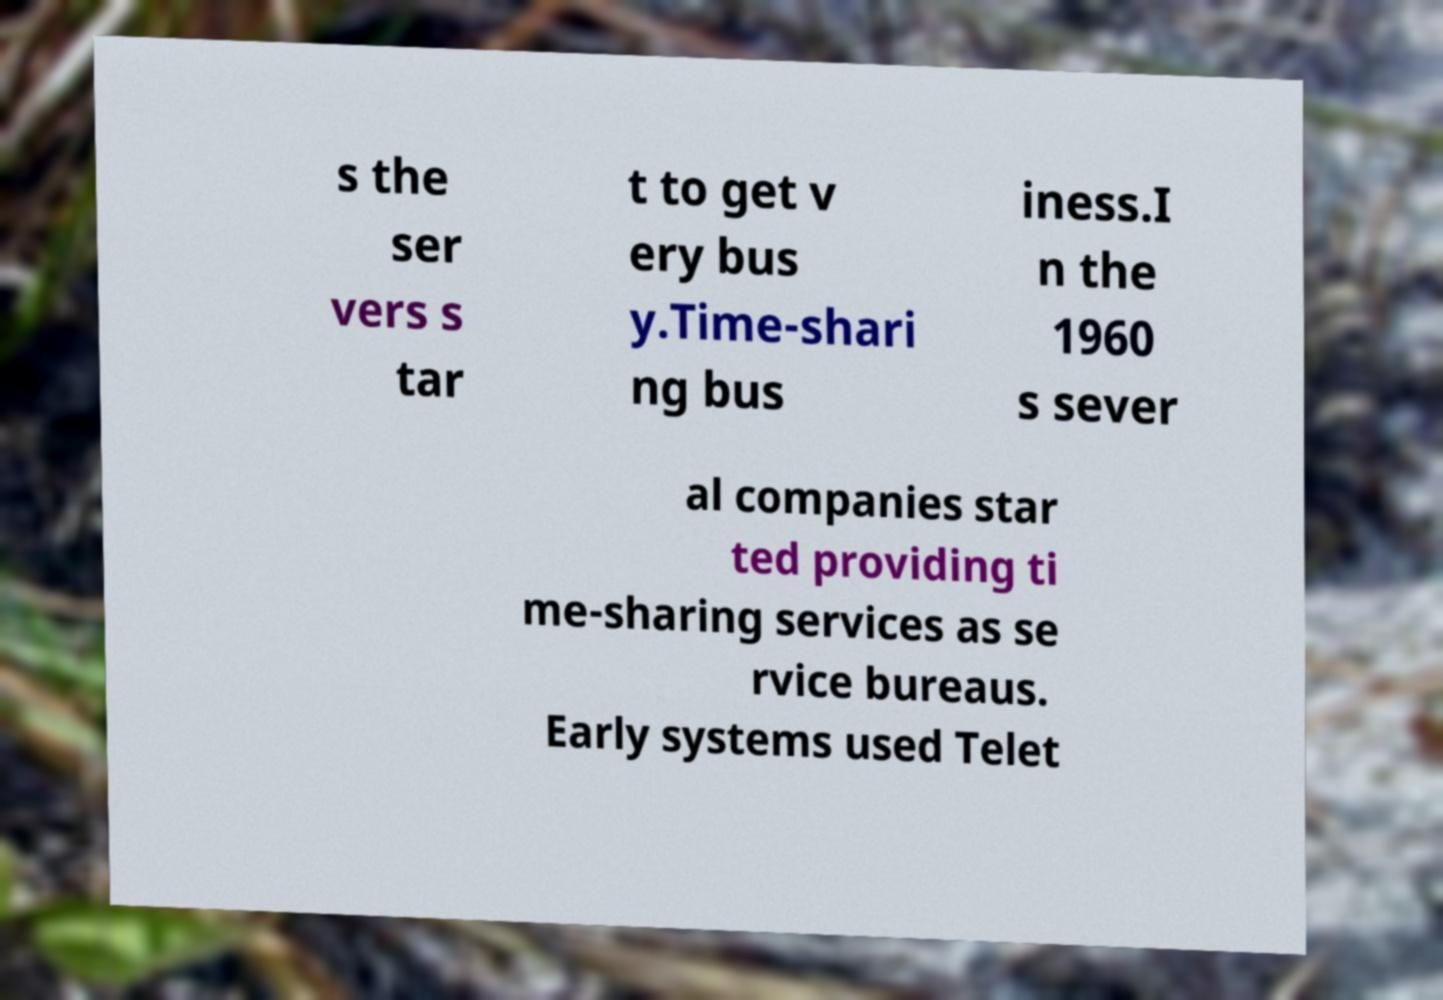I need the written content from this picture converted into text. Can you do that? s the ser vers s tar t to get v ery bus y.Time-shari ng bus iness.I n the 1960 s sever al companies star ted providing ti me-sharing services as se rvice bureaus. Early systems used Telet 